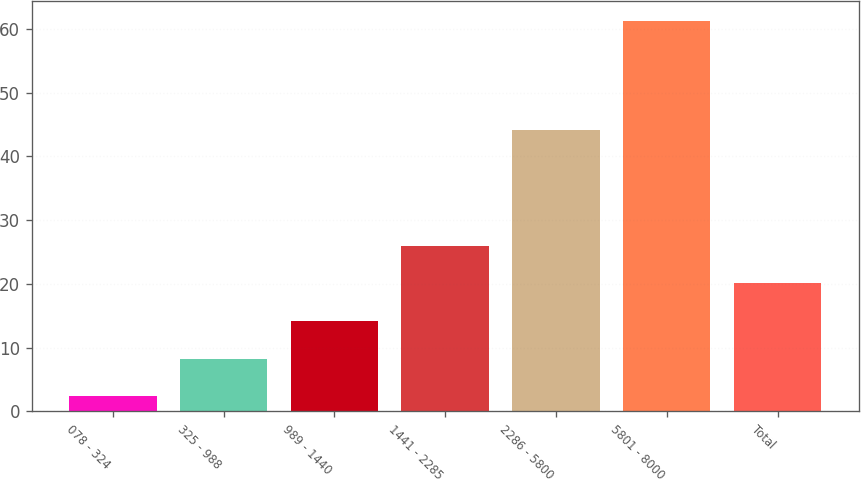Convert chart. <chart><loc_0><loc_0><loc_500><loc_500><bar_chart><fcel>078 - 324<fcel>325 - 988<fcel>989 - 1440<fcel>1441 - 2285<fcel>2286 - 5800<fcel>5801 - 8000<fcel>Total<nl><fcel>2.4<fcel>8.29<fcel>14.18<fcel>25.96<fcel>44.09<fcel>61.28<fcel>20.07<nl></chart> 